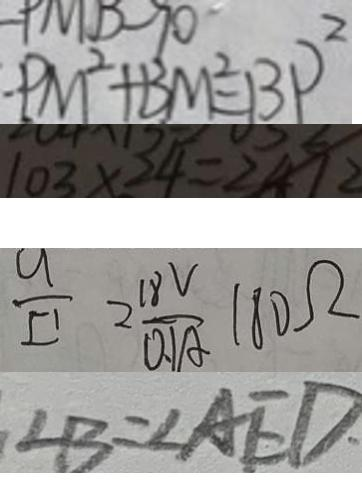Convert formula to latex. <formula><loc_0><loc_0><loc_500><loc_500>P M ^ { 2 } + B M ^ { 2 } = B P ^ { 2 } 
 1 0 3 \times 2 4 = 2 4 1 2 
 \frac { u } { I ^ { \prime } } = \frac { 1 8 V } { 0 . 1 A } 1 8 0 \Omega 
 \angle B = \angle A E D</formula> 